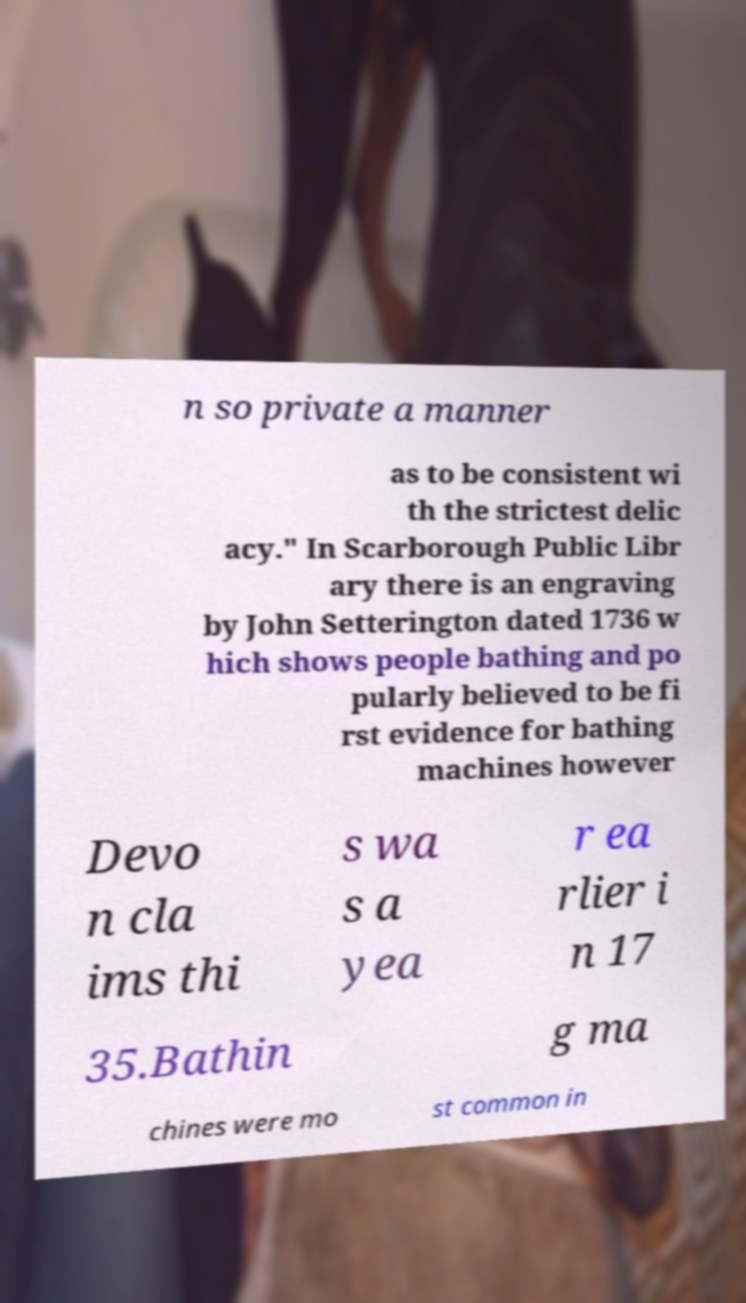Please identify and transcribe the text found in this image. n so private a manner as to be consistent wi th the strictest delic acy." In Scarborough Public Libr ary there is an engraving by John Setterington dated 1736 w hich shows people bathing and po pularly believed to be fi rst evidence for bathing machines however Devo n cla ims thi s wa s a yea r ea rlier i n 17 35.Bathin g ma chines were mo st common in 